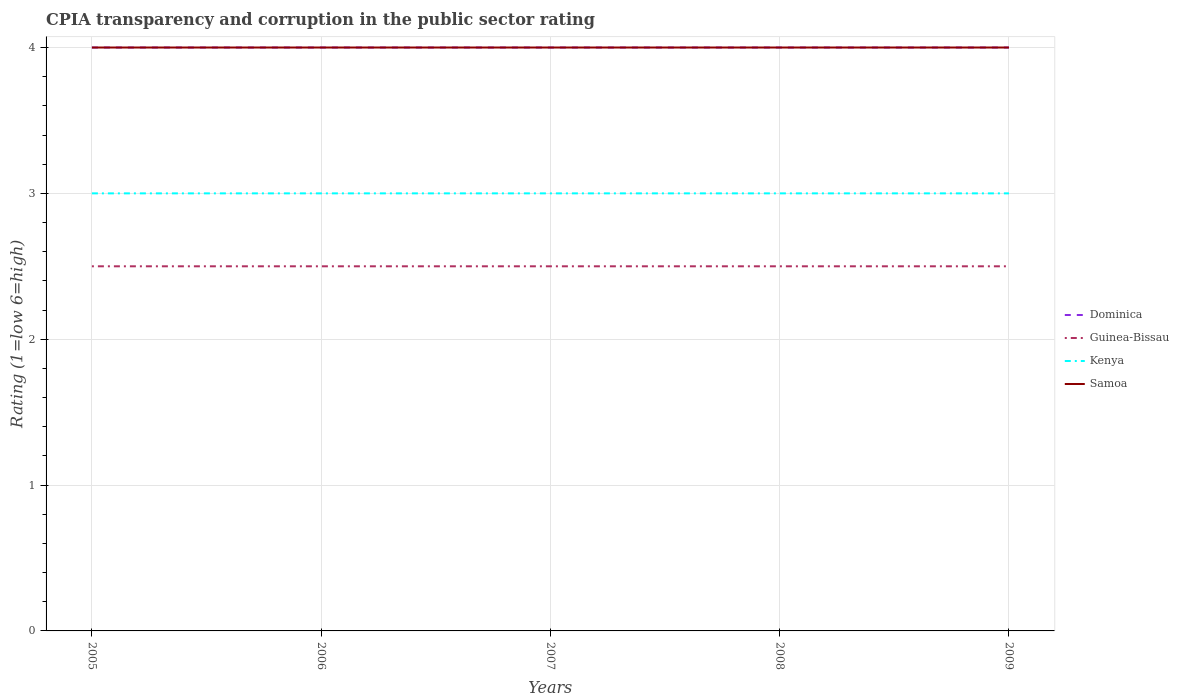Across all years, what is the maximum CPIA rating in Samoa?
Ensure brevity in your answer.  4. What is the total CPIA rating in Dominica in the graph?
Give a very brief answer. 0. How many lines are there?
Provide a short and direct response. 4. How many years are there in the graph?
Your answer should be very brief. 5. What is the difference between two consecutive major ticks on the Y-axis?
Offer a very short reply. 1. How many legend labels are there?
Offer a terse response. 4. What is the title of the graph?
Offer a terse response. CPIA transparency and corruption in the public sector rating. What is the label or title of the X-axis?
Your response must be concise. Years. What is the label or title of the Y-axis?
Provide a short and direct response. Rating (1=low 6=high). What is the Rating (1=low 6=high) of Dominica in 2005?
Provide a short and direct response. 4. What is the Rating (1=low 6=high) of Dominica in 2006?
Your answer should be very brief. 4. What is the Rating (1=low 6=high) of Guinea-Bissau in 2006?
Give a very brief answer. 2.5. What is the Rating (1=low 6=high) in Guinea-Bissau in 2007?
Ensure brevity in your answer.  2.5. What is the Rating (1=low 6=high) of Kenya in 2007?
Make the answer very short. 3. What is the Rating (1=low 6=high) in Samoa in 2007?
Your answer should be very brief. 4. What is the Rating (1=low 6=high) of Dominica in 2008?
Provide a short and direct response. 4. What is the Rating (1=low 6=high) in Kenya in 2008?
Your answer should be compact. 3. What is the Rating (1=low 6=high) in Dominica in 2009?
Your response must be concise. 4. What is the Rating (1=low 6=high) in Guinea-Bissau in 2009?
Make the answer very short. 2.5. What is the Rating (1=low 6=high) in Kenya in 2009?
Your response must be concise. 3. Across all years, what is the maximum Rating (1=low 6=high) of Dominica?
Offer a very short reply. 4. Across all years, what is the maximum Rating (1=low 6=high) of Guinea-Bissau?
Your response must be concise. 2.5. Across all years, what is the minimum Rating (1=low 6=high) in Dominica?
Your response must be concise. 4. Across all years, what is the minimum Rating (1=low 6=high) in Guinea-Bissau?
Make the answer very short. 2.5. Across all years, what is the minimum Rating (1=low 6=high) in Samoa?
Ensure brevity in your answer.  4. What is the total Rating (1=low 6=high) of Guinea-Bissau in the graph?
Your answer should be compact. 12.5. What is the total Rating (1=low 6=high) in Kenya in the graph?
Keep it short and to the point. 15. What is the difference between the Rating (1=low 6=high) in Guinea-Bissau in 2005 and that in 2007?
Ensure brevity in your answer.  0. What is the difference between the Rating (1=low 6=high) in Kenya in 2005 and that in 2007?
Your answer should be compact. 0. What is the difference between the Rating (1=low 6=high) of Dominica in 2005 and that in 2008?
Provide a short and direct response. 0. What is the difference between the Rating (1=low 6=high) in Guinea-Bissau in 2005 and that in 2008?
Your answer should be compact. 0. What is the difference between the Rating (1=low 6=high) in Kenya in 2005 and that in 2008?
Your response must be concise. 0. What is the difference between the Rating (1=low 6=high) of Samoa in 2005 and that in 2008?
Give a very brief answer. 0. What is the difference between the Rating (1=low 6=high) in Guinea-Bissau in 2005 and that in 2009?
Offer a terse response. 0. What is the difference between the Rating (1=low 6=high) of Guinea-Bissau in 2006 and that in 2007?
Your answer should be very brief. 0. What is the difference between the Rating (1=low 6=high) of Kenya in 2006 and that in 2007?
Provide a short and direct response. 0. What is the difference between the Rating (1=low 6=high) of Guinea-Bissau in 2006 and that in 2008?
Give a very brief answer. 0. What is the difference between the Rating (1=low 6=high) of Kenya in 2006 and that in 2009?
Provide a short and direct response. 0. What is the difference between the Rating (1=low 6=high) of Samoa in 2006 and that in 2009?
Your answer should be compact. 0. What is the difference between the Rating (1=low 6=high) of Dominica in 2007 and that in 2008?
Provide a short and direct response. 0. What is the difference between the Rating (1=low 6=high) of Guinea-Bissau in 2007 and that in 2008?
Keep it short and to the point. 0. What is the difference between the Rating (1=low 6=high) of Samoa in 2007 and that in 2008?
Give a very brief answer. 0. What is the difference between the Rating (1=low 6=high) of Dominica in 2007 and that in 2009?
Provide a succinct answer. 0. What is the difference between the Rating (1=low 6=high) of Kenya in 2008 and that in 2009?
Give a very brief answer. 0. What is the difference between the Rating (1=low 6=high) in Samoa in 2008 and that in 2009?
Offer a very short reply. 0. What is the difference between the Rating (1=low 6=high) in Dominica in 2005 and the Rating (1=low 6=high) in Guinea-Bissau in 2006?
Ensure brevity in your answer.  1.5. What is the difference between the Rating (1=low 6=high) in Dominica in 2005 and the Rating (1=low 6=high) in Samoa in 2006?
Your answer should be compact. 0. What is the difference between the Rating (1=low 6=high) of Guinea-Bissau in 2005 and the Rating (1=low 6=high) of Kenya in 2006?
Give a very brief answer. -0.5. What is the difference between the Rating (1=low 6=high) of Guinea-Bissau in 2005 and the Rating (1=low 6=high) of Samoa in 2006?
Make the answer very short. -1.5. What is the difference between the Rating (1=low 6=high) in Kenya in 2005 and the Rating (1=low 6=high) in Samoa in 2006?
Offer a very short reply. -1. What is the difference between the Rating (1=low 6=high) of Dominica in 2005 and the Rating (1=low 6=high) of Guinea-Bissau in 2007?
Ensure brevity in your answer.  1.5. What is the difference between the Rating (1=low 6=high) of Dominica in 2005 and the Rating (1=low 6=high) of Samoa in 2007?
Provide a succinct answer. 0. What is the difference between the Rating (1=low 6=high) in Kenya in 2005 and the Rating (1=low 6=high) in Samoa in 2007?
Your response must be concise. -1. What is the difference between the Rating (1=low 6=high) in Dominica in 2005 and the Rating (1=low 6=high) in Guinea-Bissau in 2008?
Give a very brief answer. 1.5. What is the difference between the Rating (1=low 6=high) in Dominica in 2005 and the Rating (1=low 6=high) in Kenya in 2008?
Your answer should be very brief. 1. What is the difference between the Rating (1=low 6=high) in Dominica in 2005 and the Rating (1=low 6=high) in Samoa in 2008?
Ensure brevity in your answer.  0. What is the difference between the Rating (1=low 6=high) of Guinea-Bissau in 2005 and the Rating (1=low 6=high) of Samoa in 2008?
Keep it short and to the point. -1.5. What is the difference between the Rating (1=low 6=high) of Kenya in 2005 and the Rating (1=low 6=high) of Samoa in 2008?
Provide a succinct answer. -1. What is the difference between the Rating (1=low 6=high) of Dominica in 2005 and the Rating (1=low 6=high) of Guinea-Bissau in 2009?
Make the answer very short. 1.5. What is the difference between the Rating (1=low 6=high) in Dominica in 2005 and the Rating (1=low 6=high) in Samoa in 2009?
Your answer should be compact. 0. What is the difference between the Rating (1=low 6=high) in Guinea-Bissau in 2005 and the Rating (1=low 6=high) in Kenya in 2009?
Keep it short and to the point. -0.5. What is the difference between the Rating (1=low 6=high) of Dominica in 2006 and the Rating (1=low 6=high) of Guinea-Bissau in 2007?
Offer a very short reply. 1.5. What is the difference between the Rating (1=low 6=high) in Dominica in 2006 and the Rating (1=low 6=high) in Kenya in 2007?
Give a very brief answer. 1. What is the difference between the Rating (1=low 6=high) in Dominica in 2006 and the Rating (1=low 6=high) in Samoa in 2007?
Your response must be concise. 0. What is the difference between the Rating (1=low 6=high) of Guinea-Bissau in 2006 and the Rating (1=low 6=high) of Kenya in 2007?
Your response must be concise. -0.5. What is the difference between the Rating (1=low 6=high) of Guinea-Bissau in 2006 and the Rating (1=low 6=high) of Samoa in 2007?
Keep it short and to the point. -1.5. What is the difference between the Rating (1=low 6=high) of Dominica in 2006 and the Rating (1=low 6=high) of Guinea-Bissau in 2008?
Offer a terse response. 1.5. What is the difference between the Rating (1=low 6=high) in Guinea-Bissau in 2006 and the Rating (1=low 6=high) in Samoa in 2008?
Your answer should be compact. -1.5. What is the difference between the Rating (1=low 6=high) in Guinea-Bissau in 2006 and the Rating (1=low 6=high) in Samoa in 2009?
Make the answer very short. -1.5. What is the difference between the Rating (1=low 6=high) in Kenya in 2006 and the Rating (1=low 6=high) in Samoa in 2009?
Ensure brevity in your answer.  -1. What is the difference between the Rating (1=low 6=high) of Dominica in 2007 and the Rating (1=low 6=high) of Guinea-Bissau in 2008?
Keep it short and to the point. 1.5. What is the difference between the Rating (1=low 6=high) in Dominica in 2007 and the Rating (1=low 6=high) in Kenya in 2008?
Provide a succinct answer. 1. What is the difference between the Rating (1=low 6=high) of Dominica in 2007 and the Rating (1=low 6=high) of Samoa in 2008?
Your answer should be compact. 0. What is the difference between the Rating (1=low 6=high) in Dominica in 2007 and the Rating (1=low 6=high) in Guinea-Bissau in 2009?
Make the answer very short. 1.5. What is the difference between the Rating (1=low 6=high) in Dominica in 2007 and the Rating (1=low 6=high) in Kenya in 2009?
Ensure brevity in your answer.  1. What is the difference between the Rating (1=low 6=high) of Dominica in 2007 and the Rating (1=low 6=high) of Samoa in 2009?
Make the answer very short. 0. What is the difference between the Rating (1=low 6=high) of Guinea-Bissau in 2007 and the Rating (1=low 6=high) of Kenya in 2009?
Offer a very short reply. -0.5. What is the difference between the Rating (1=low 6=high) of Guinea-Bissau in 2007 and the Rating (1=low 6=high) of Samoa in 2009?
Keep it short and to the point. -1.5. What is the difference between the Rating (1=low 6=high) of Dominica in 2008 and the Rating (1=low 6=high) of Kenya in 2009?
Give a very brief answer. 1. What is the difference between the Rating (1=low 6=high) of Guinea-Bissau in 2008 and the Rating (1=low 6=high) of Samoa in 2009?
Keep it short and to the point. -1.5. What is the difference between the Rating (1=low 6=high) of Kenya in 2008 and the Rating (1=low 6=high) of Samoa in 2009?
Give a very brief answer. -1. What is the average Rating (1=low 6=high) in Dominica per year?
Keep it short and to the point. 4. What is the average Rating (1=low 6=high) of Kenya per year?
Your response must be concise. 3. What is the average Rating (1=low 6=high) of Samoa per year?
Your answer should be very brief. 4. In the year 2005, what is the difference between the Rating (1=low 6=high) in Dominica and Rating (1=low 6=high) in Guinea-Bissau?
Keep it short and to the point. 1.5. In the year 2005, what is the difference between the Rating (1=low 6=high) of Dominica and Rating (1=low 6=high) of Samoa?
Your answer should be very brief. 0. In the year 2005, what is the difference between the Rating (1=low 6=high) in Guinea-Bissau and Rating (1=low 6=high) in Kenya?
Your response must be concise. -0.5. In the year 2005, what is the difference between the Rating (1=low 6=high) in Guinea-Bissau and Rating (1=low 6=high) in Samoa?
Offer a very short reply. -1.5. In the year 2006, what is the difference between the Rating (1=low 6=high) in Dominica and Rating (1=low 6=high) in Kenya?
Offer a very short reply. 1. In the year 2006, what is the difference between the Rating (1=low 6=high) of Guinea-Bissau and Rating (1=low 6=high) of Kenya?
Make the answer very short. -0.5. In the year 2006, what is the difference between the Rating (1=low 6=high) of Guinea-Bissau and Rating (1=low 6=high) of Samoa?
Provide a short and direct response. -1.5. In the year 2007, what is the difference between the Rating (1=low 6=high) of Dominica and Rating (1=low 6=high) of Kenya?
Provide a succinct answer. 1. In the year 2007, what is the difference between the Rating (1=low 6=high) in Guinea-Bissau and Rating (1=low 6=high) in Samoa?
Offer a terse response. -1.5. In the year 2008, what is the difference between the Rating (1=low 6=high) of Dominica and Rating (1=low 6=high) of Guinea-Bissau?
Provide a succinct answer. 1.5. In the year 2009, what is the difference between the Rating (1=low 6=high) of Dominica and Rating (1=low 6=high) of Guinea-Bissau?
Make the answer very short. 1.5. In the year 2009, what is the difference between the Rating (1=low 6=high) in Dominica and Rating (1=low 6=high) in Samoa?
Offer a very short reply. 0. In the year 2009, what is the difference between the Rating (1=low 6=high) of Guinea-Bissau and Rating (1=low 6=high) of Kenya?
Your answer should be compact. -0.5. What is the ratio of the Rating (1=low 6=high) of Guinea-Bissau in 2005 to that in 2006?
Provide a short and direct response. 1. What is the ratio of the Rating (1=low 6=high) in Samoa in 2005 to that in 2006?
Give a very brief answer. 1. What is the ratio of the Rating (1=low 6=high) in Samoa in 2005 to that in 2007?
Your response must be concise. 1. What is the ratio of the Rating (1=low 6=high) of Kenya in 2005 to that in 2008?
Ensure brevity in your answer.  1. What is the ratio of the Rating (1=low 6=high) of Dominica in 2005 to that in 2009?
Give a very brief answer. 1. What is the ratio of the Rating (1=low 6=high) in Guinea-Bissau in 2005 to that in 2009?
Your answer should be very brief. 1. What is the ratio of the Rating (1=low 6=high) in Kenya in 2005 to that in 2009?
Your answer should be compact. 1. What is the ratio of the Rating (1=low 6=high) of Kenya in 2006 to that in 2007?
Your answer should be compact. 1. What is the ratio of the Rating (1=low 6=high) in Samoa in 2006 to that in 2007?
Provide a short and direct response. 1. What is the ratio of the Rating (1=low 6=high) in Dominica in 2006 to that in 2008?
Your answer should be compact. 1. What is the ratio of the Rating (1=low 6=high) in Samoa in 2006 to that in 2008?
Offer a terse response. 1. What is the ratio of the Rating (1=low 6=high) in Dominica in 2006 to that in 2009?
Your answer should be very brief. 1. What is the ratio of the Rating (1=low 6=high) in Guinea-Bissau in 2006 to that in 2009?
Keep it short and to the point. 1. What is the ratio of the Rating (1=low 6=high) in Kenya in 2006 to that in 2009?
Keep it short and to the point. 1. What is the ratio of the Rating (1=low 6=high) in Samoa in 2006 to that in 2009?
Provide a short and direct response. 1. What is the ratio of the Rating (1=low 6=high) of Guinea-Bissau in 2007 to that in 2008?
Provide a succinct answer. 1. What is the ratio of the Rating (1=low 6=high) in Dominica in 2007 to that in 2009?
Provide a succinct answer. 1. What is the ratio of the Rating (1=low 6=high) of Kenya in 2007 to that in 2009?
Your response must be concise. 1. What is the ratio of the Rating (1=low 6=high) of Samoa in 2007 to that in 2009?
Keep it short and to the point. 1. What is the ratio of the Rating (1=low 6=high) of Guinea-Bissau in 2008 to that in 2009?
Your response must be concise. 1. What is the difference between the highest and the second highest Rating (1=low 6=high) of Kenya?
Your answer should be very brief. 0. What is the difference between the highest and the second highest Rating (1=low 6=high) of Samoa?
Your response must be concise. 0. What is the difference between the highest and the lowest Rating (1=low 6=high) in Samoa?
Your response must be concise. 0. 